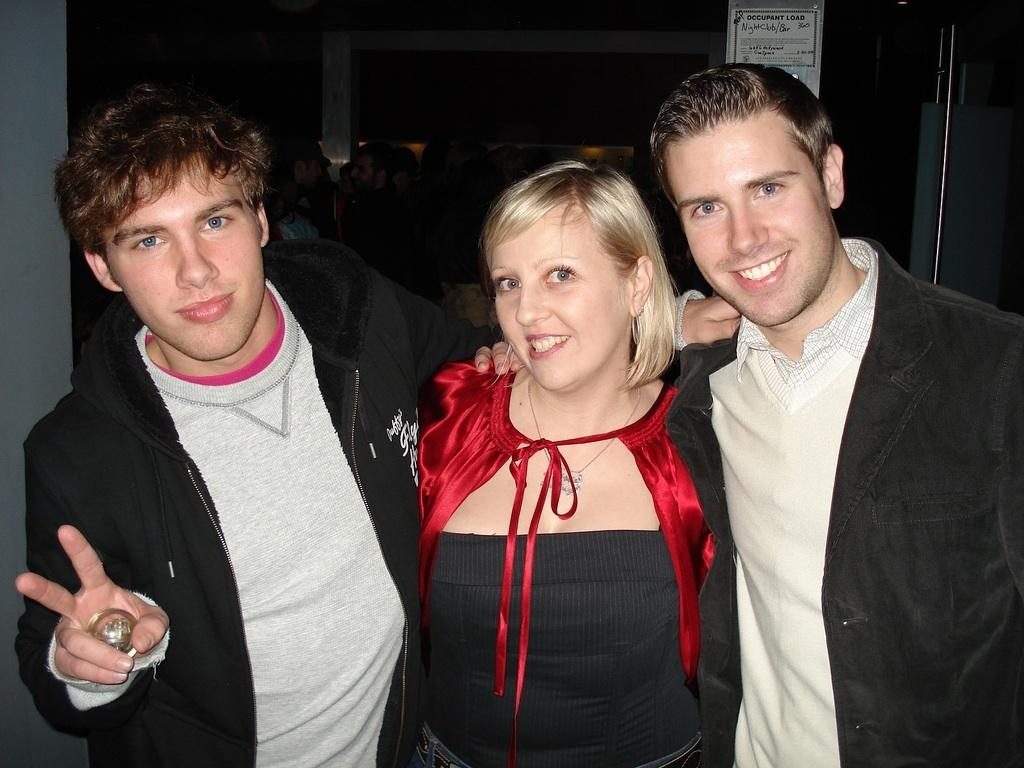How many people are standing at the bottom of the image? There are three persons standing at the bottom of the image. What is the person on the left side holding? The person on the left side is holding an object. Can you describe the other persons in the image? There are other persons standing in the background of the image. What type of smile can be seen on the zebra in the image? There is no zebra present in the image, so it is not possible to answer that question. 